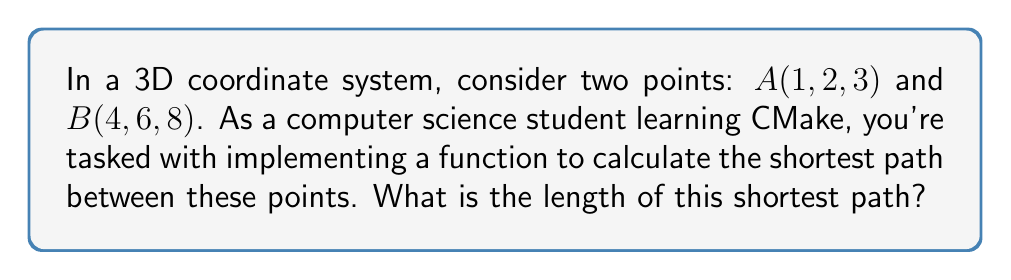Teach me how to tackle this problem. To solve this problem, we'll use the following steps:

1. Recognize that the shortest path between two points in 3D space is a straight line.

2. To find the length of this line, we can use the 3D distance formula, which is an extension of the Pythagorean theorem to three dimensions:

   $$d = \sqrt{(x_2 - x_1)^2 + (y_2 - y_1)^2 + (z_2 - z_1)^2}$$

   Where $(x_1, y_1, z_1)$ are the coordinates of the first point and $(x_2, y_2, z_2)$ are the coordinates of the second point.

3. Substitute the given coordinates into the formula:
   
   $$d = \sqrt{(4 - 1)^2 + (6 - 2)^2 + (8 - 3)^2}$$

4. Simplify the expressions inside the parentheses:
   
   $$d = \sqrt{3^2 + 4^2 + 5^2}$$

5. Calculate the squares:
   
   $$d = \sqrt{9 + 16 + 25}$$

6. Sum the values under the square root:
   
   $$d = \sqrt{50}$$

7. Simplify the square root:
   
   $$d = 5\sqrt{2}$$

This result, $5\sqrt{2}$, represents the length of the shortest path between points A and B in the 3D space.
Answer: $5\sqrt{2}$ 